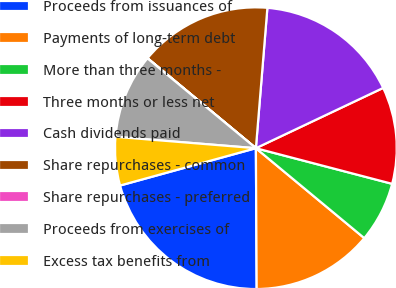Convert chart to OTSL. <chart><loc_0><loc_0><loc_500><loc_500><pie_chart><fcel>Proceeds from issuances of<fcel>Payments of long-term debt<fcel>More than three months -<fcel>Three months or less net<fcel>Cash dividends paid<fcel>Share repurchases - common<fcel>Share repurchases - preferred<fcel>Proceeds from exercises of<fcel>Excess tax benefits from<nl><fcel>20.82%<fcel>13.89%<fcel>6.95%<fcel>11.11%<fcel>16.66%<fcel>15.27%<fcel>0.02%<fcel>9.72%<fcel>5.56%<nl></chart> 